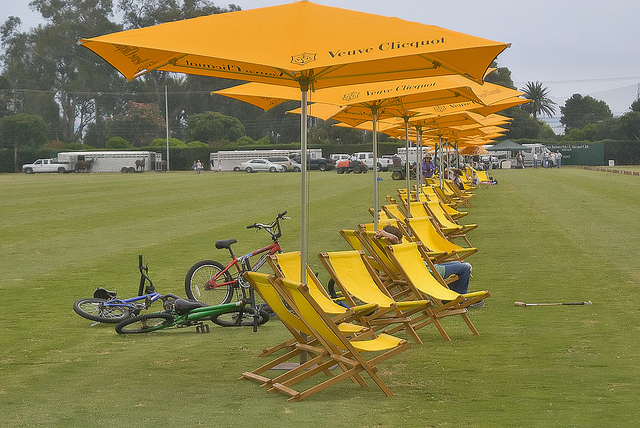Identify and read out the text in this image. Veuve Clicquol 